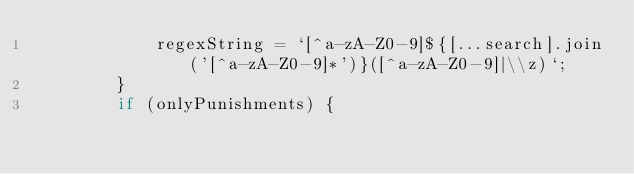Convert code to text. <code><loc_0><loc_0><loc_500><loc_500><_TypeScript_>			regexString = `[^a-zA-Z0-9]${[...search].join('[^a-zA-Z0-9]*')}([^a-zA-Z0-9]|\\z)`;
		}
		if (onlyPunishments) {</code> 